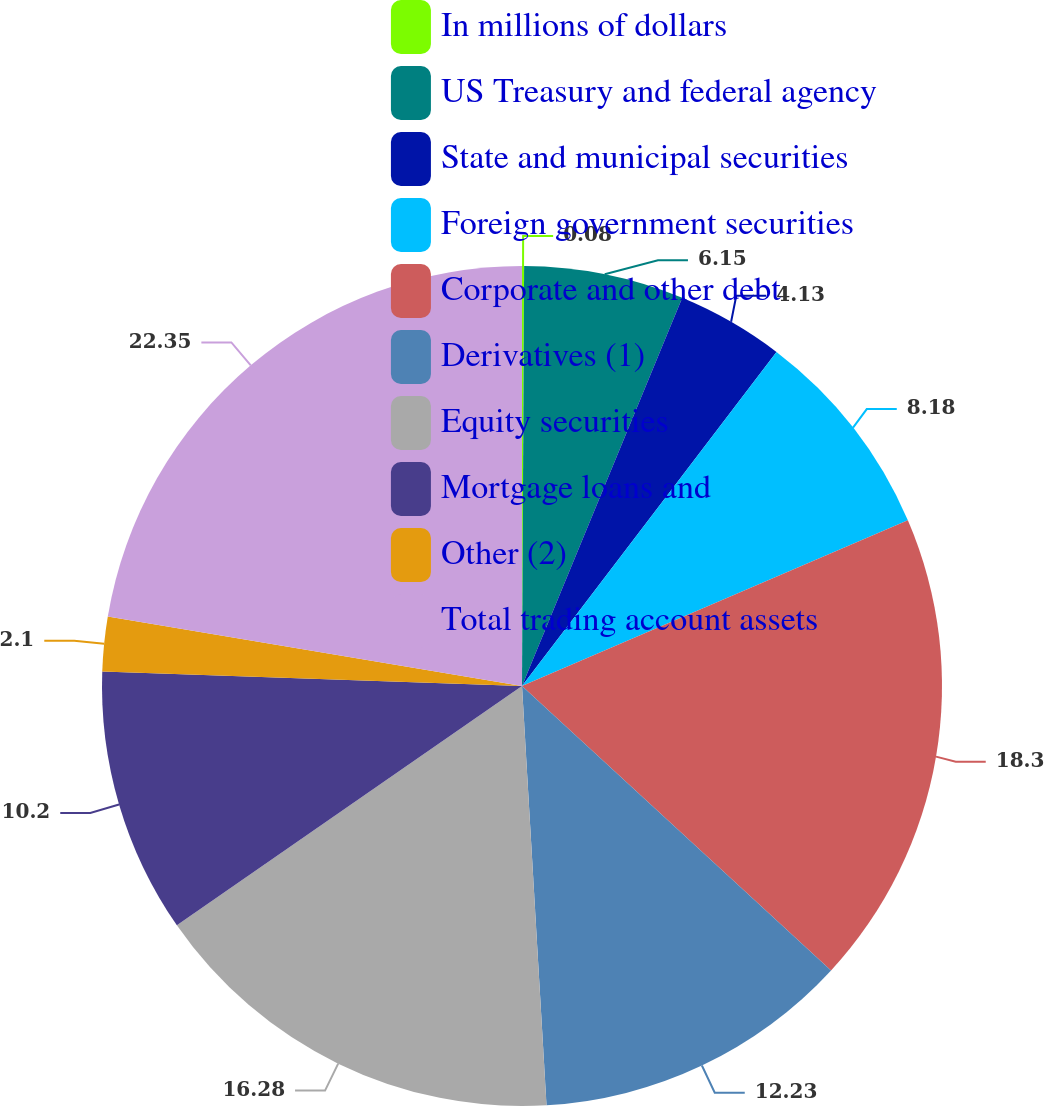Convert chart to OTSL. <chart><loc_0><loc_0><loc_500><loc_500><pie_chart><fcel>In millions of dollars<fcel>US Treasury and federal agency<fcel>State and municipal securities<fcel>Foreign government securities<fcel>Corporate and other debt<fcel>Derivatives (1)<fcel>Equity securities<fcel>Mortgage loans and<fcel>Other (2)<fcel>Total trading account assets<nl><fcel>0.08%<fcel>6.15%<fcel>4.13%<fcel>8.18%<fcel>18.3%<fcel>12.23%<fcel>16.28%<fcel>10.2%<fcel>2.1%<fcel>22.35%<nl></chart> 